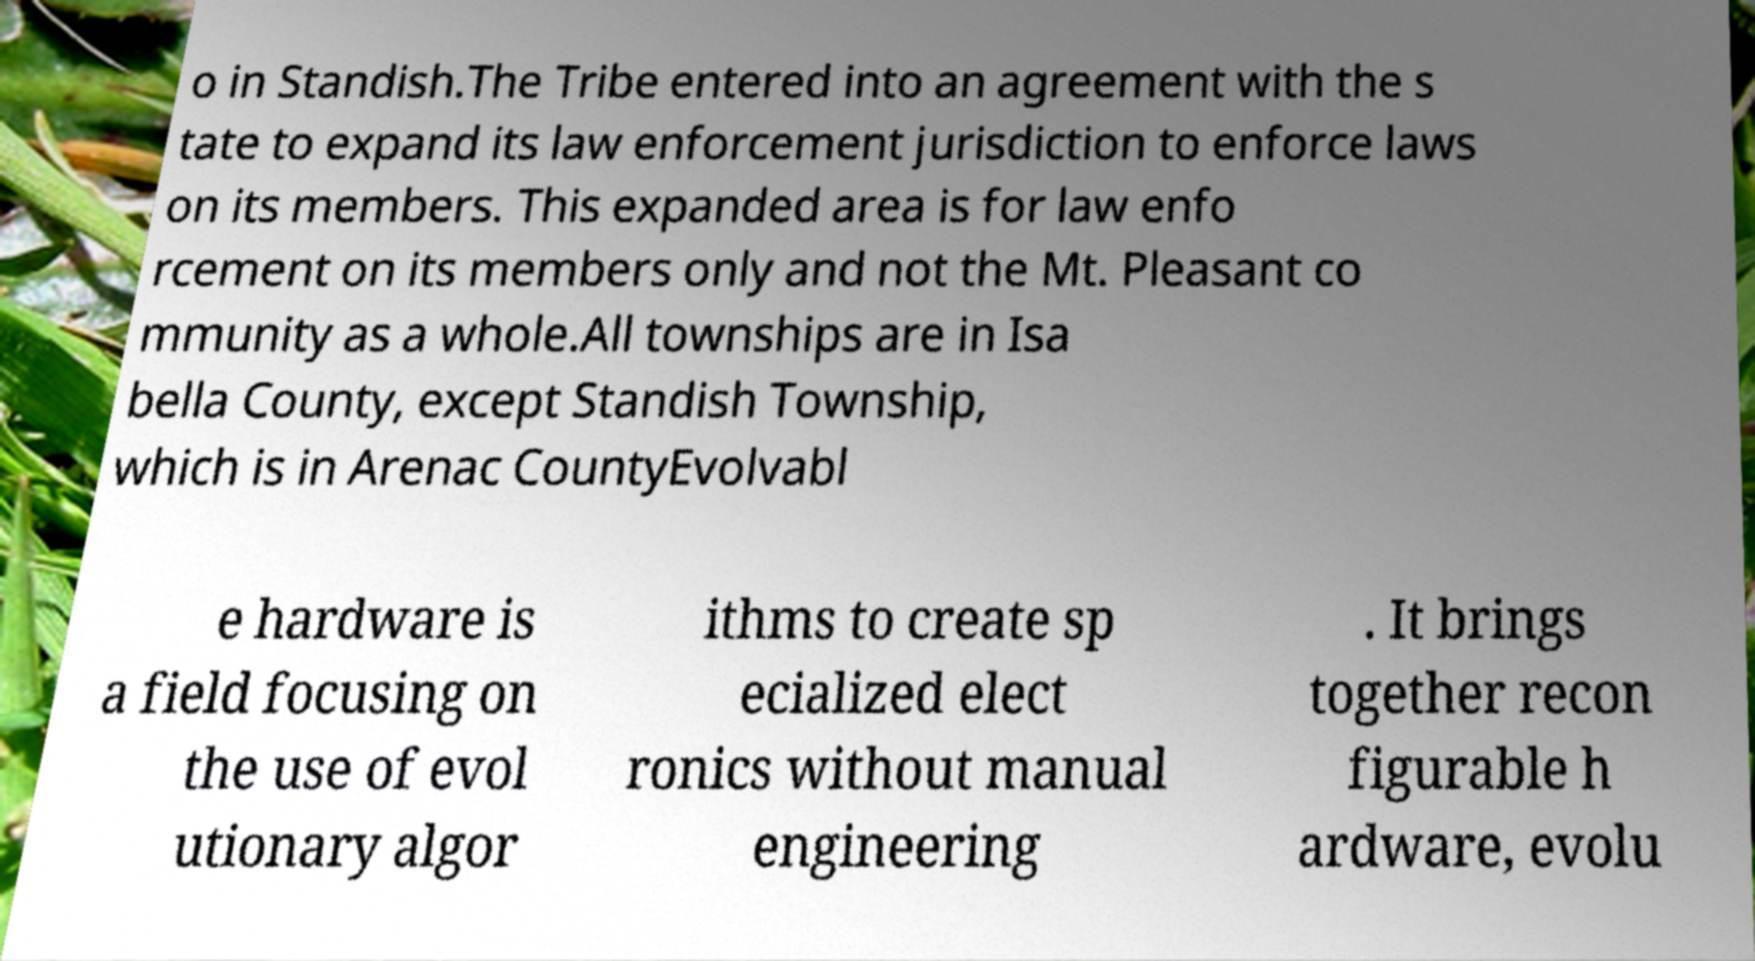Please read and relay the text visible in this image. What does it say? o in Standish.The Tribe entered into an agreement with the s tate to expand its law enforcement jurisdiction to enforce laws on its members. This expanded area is for law enfo rcement on its members only and not the Mt. Pleasant co mmunity as a whole.All townships are in Isa bella County, except Standish Township, which is in Arenac CountyEvolvabl e hardware is a field focusing on the use of evol utionary algor ithms to create sp ecialized elect ronics without manual engineering . It brings together recon figurable h ardware, evolu 